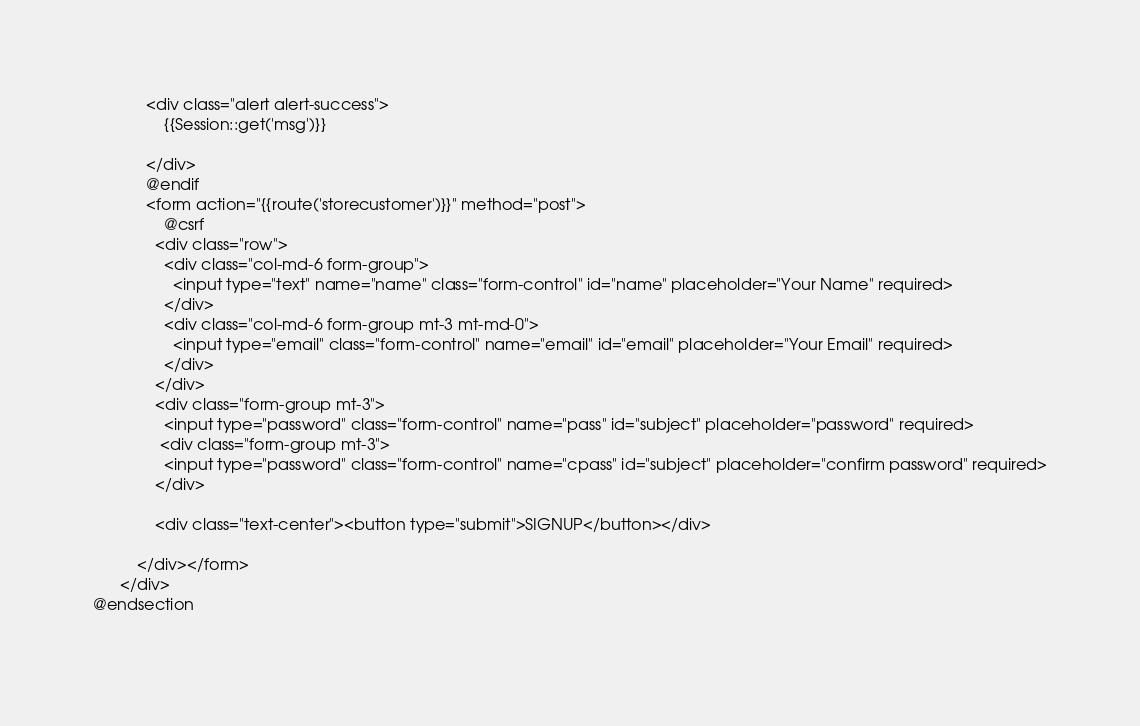Convert code to text. <code><loc_0><loc_0><loc_500><loc_500><_PHP_>			<div class="alert alert-success">
				{{Session::get('msg')}}
				
			</div>
			@endif
            <form action="{{route('storecustomer')}}" method="post">
            	@csrf
              <div class="row">
                <div class="col-md-6 form-group">
                  <input type="text" name="name" class="form-control" id="name" placeholder="Your Name" required>
                </div>
                <div class="col-md-6 form-group mt-3 mt-md-0">
                  <input type="email" class="form-control" name="email" id="email" placeholder="Your Email" required>
                </div>
              </div>
              <div class="form-group mt-3">
                <input type="password" class="form-control" name="pass" id="subject" placeholder="password" required>
               <div class="form-group mt-3">
                <input type="password" class="form-control" name="cpass" id="subject" placeholder="confirm password" required>
              </div>
            
              <div class="text-center"><button type="submit">SIGNUP</button></div>
            
          </div></form>
      </div>
@endsection
	
</code> 